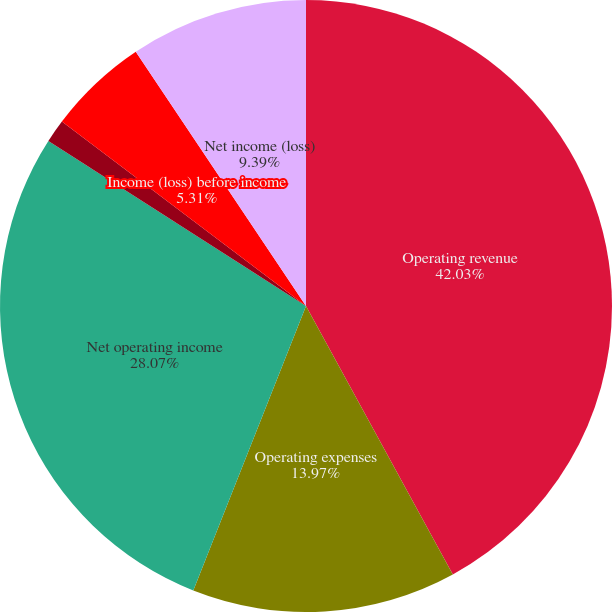Convert chart. <chart><loc_0><loc_0><loc_500><loc_500><pie_chart><fcel>Operating revenue<fcel>Operating expenses<fcel>Net operating income<fcel>Property management<fcel>Income (loss) before income<fcel>Net income (loss)<nl><fcel>42.04%<fcel>13.97%<fcel>28.07%<fcel>1.23%<fcel>5.31%<fcel>9.39%<nl></chart> 